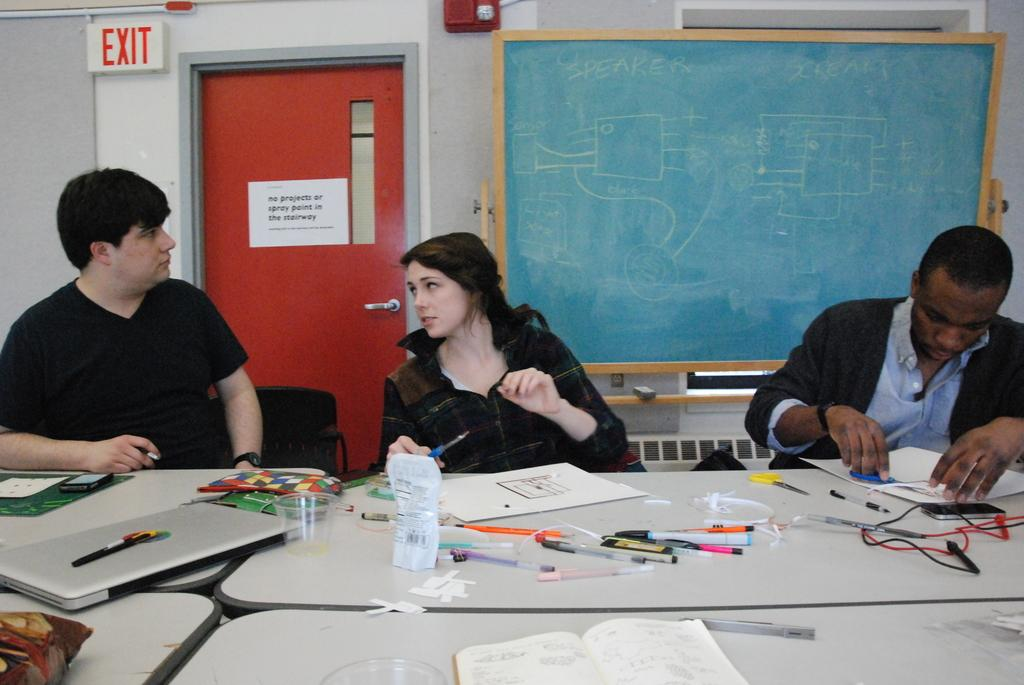How many people are in the image? There are persons in the image, but the exact number cannot be determined from the provided facts. What is the main object in the image? There is a table in the image. What electronic device is visible on the table? A laptop is visible in the image. What items might be used for reading or writing in the image? Glasses and papers are present in the image. What architectural features can be seen in the background of the image? There is a door and a board in the background of the image. What type of amusement can be seen in the image? There is no amusement present in the image; it features a table, a laptop, glasses, papers, a door, and a board. What kind of bread is being toasted in the image? There is no bread or toasting activity present in the image. 